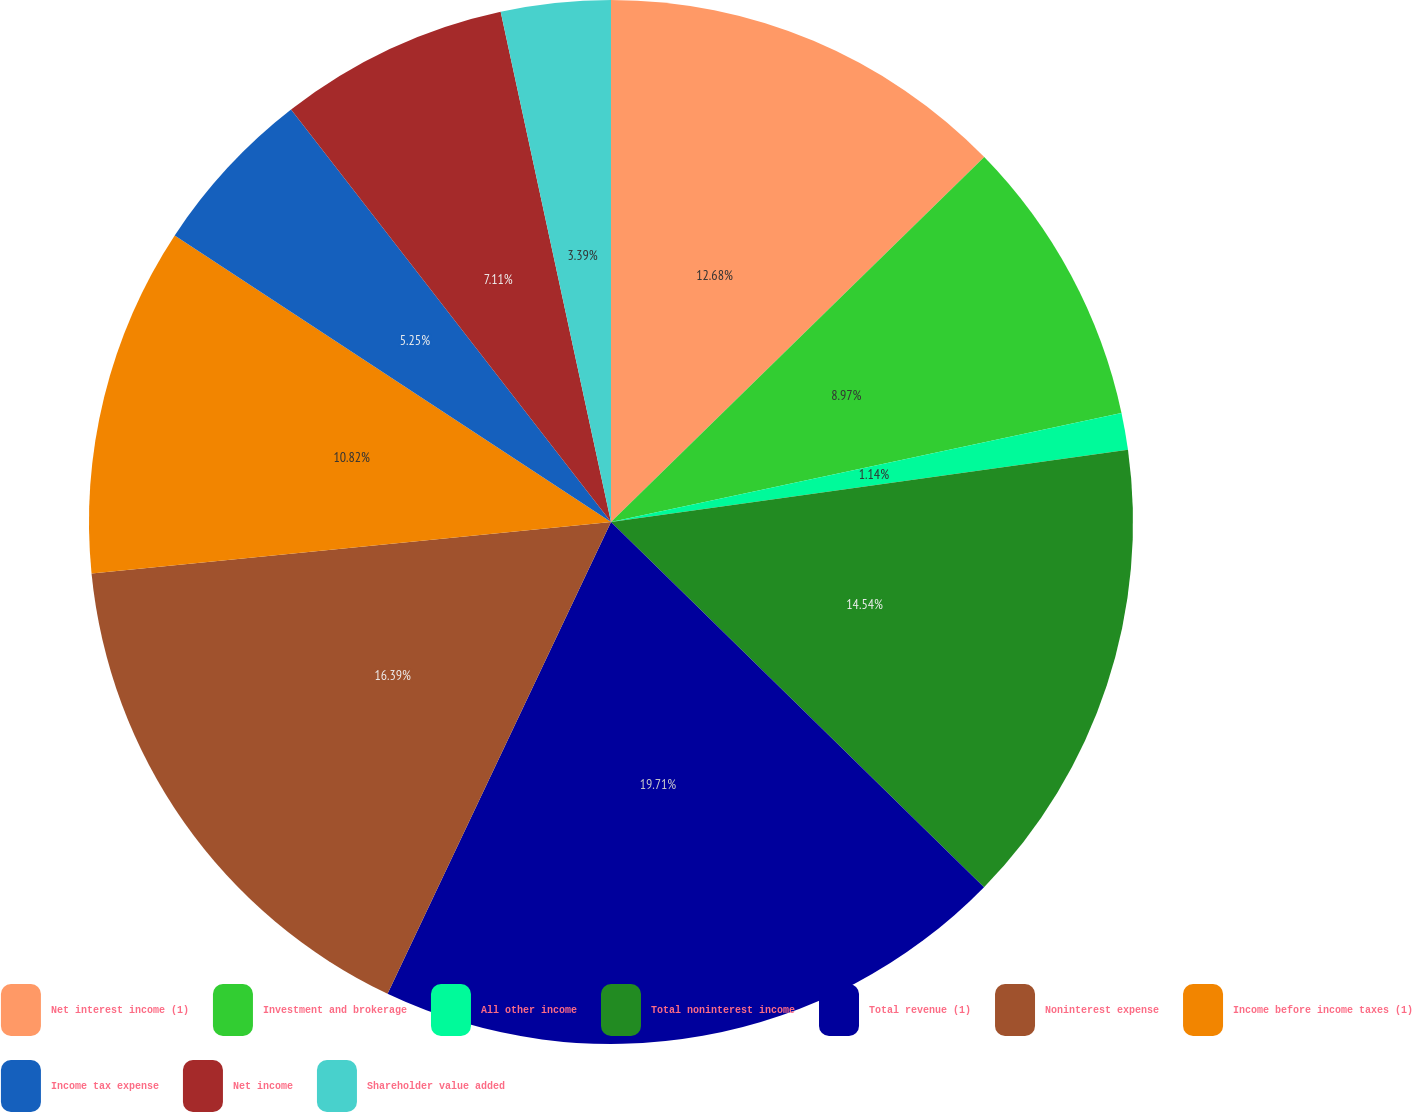Convert chart to OTSL. <chart><loc_0><loc_0><loc_500><loc_500><pie_chart><fcel>Net interest income (1)<fcel>Investment and brokerage<fcel>All other income<fcel>Total noninterest income<fcel>Total revenue (1)<fcel>Noninterest expense<fcel>Income before income taxes (1)<fcel>Income tax expense<fcel>Net income<fcel>Shareholder value added<nl><fcel>12.68%<fcel>8.97%<fcel>1.14%<fcel>14.54%<fcel>19.71%<fcel>16.39%<fcel>10.82%<fcel>5.25%<fcel>7.11%<fcel>3.39%<nl></chart> 